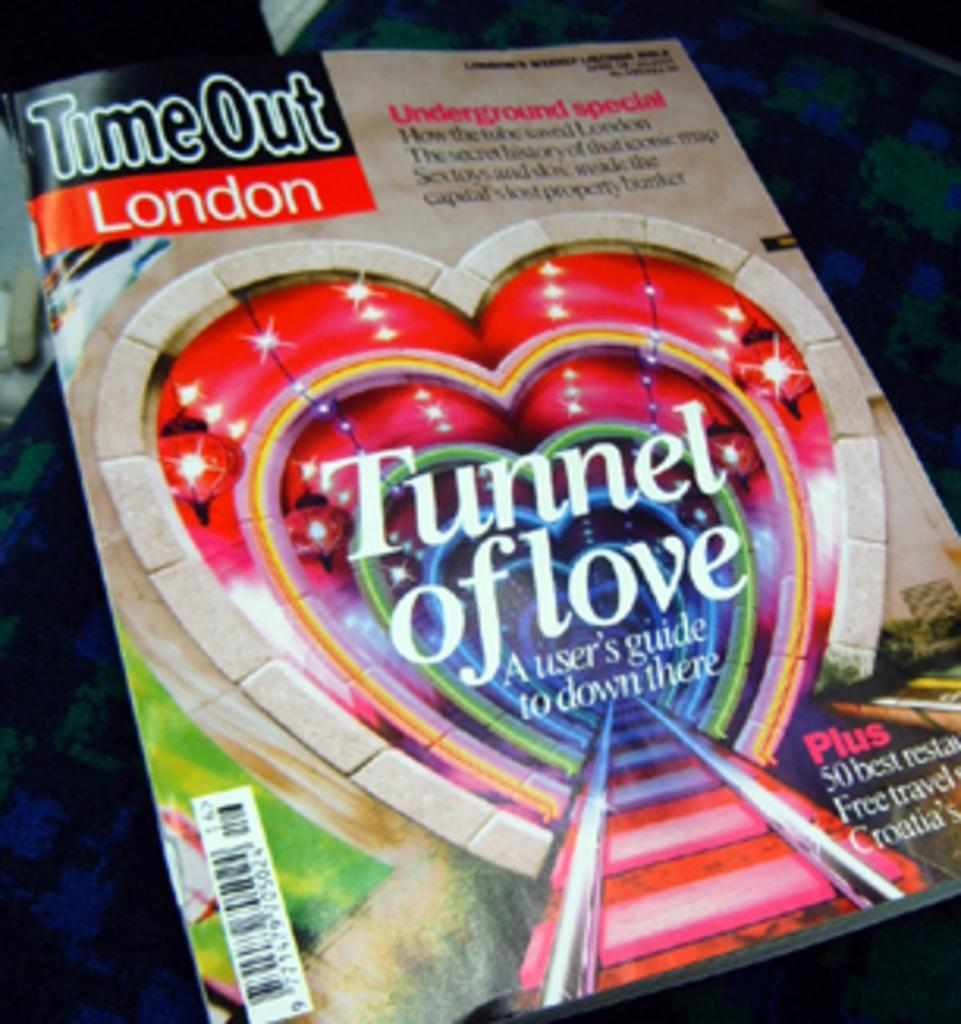<image>
Present a compact description of the photo's key features. The Tunnel of Love has a user guide on how to go down there. 